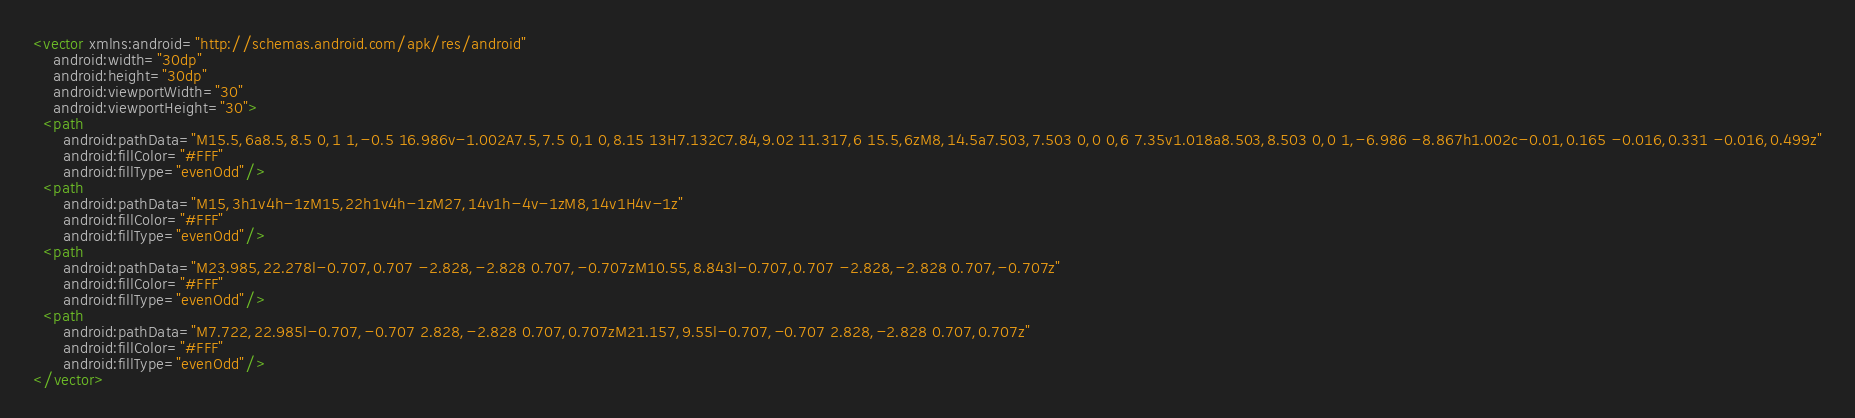Convert code to text. <code><loc_0><loc_0><loc_500><loc_500><_XML_><vector xmlns:android="http://schemas.android.com/apk/res/android"
    android:width="30dp"
    android:height="30dp"
    android:viewportWidth="30"
    android:viewportHeight="30">
  <path
      android:pathData="M15.5,6a8.5,8.5 0,1 1,-0.5 16.986v-1.002A7.5,7.5 0,1 0,8.15 13H7.132C7.84,9.02 11.317,6 15.5,6zM8,14.5a7.503,7.503 0,0 0,6 7.35v1.018a8.503,8.503 0,0 1,-6.986 -8.867h1.002c-0.01,0.165 -0.016,0.331 -0.016,0.499z"
      android:fillColor="#FFF"
      android:fillType="evenOdd"/>
  <path
      android:pathData="M15,3h1v4h-1zM15,22h1v4h-1zM27,14v1h-4v-1zM8,14v1H4v-1z"
      android:fillColor="#FFF"
      android:fillType="evenOdd"/>
  <path
      android:pathData="M23.985,22.278l-0.707,0.707 -2.828,-2.828 0.707,-0.707zM10.55,8.843l-0.707,0.707 -2.828,-2.828 0.707,-0.707z"
      android:fillColor="#FFF"
      android:fillType="evenOdd"/>
  <path
      android:pathData="M7.722,22.985l-0.707,-0.707 2.828,-2.828 0.707,0.707zM21.157,9.55l-0.707,-0.707 2.828,-2.828 0.707,0.707z"
      android:fillColor="#FFF"
      android:fillType="evenOdd"/>
</vector>
</code> 